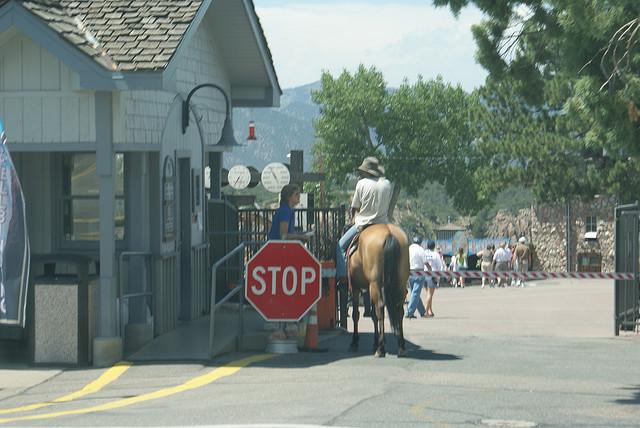What does the red sign say?
Short answer required. Stop. Is this an entrance to a park?
Concise answer only. Yes. Is the horse running downhill?
Answer briefly. No. 